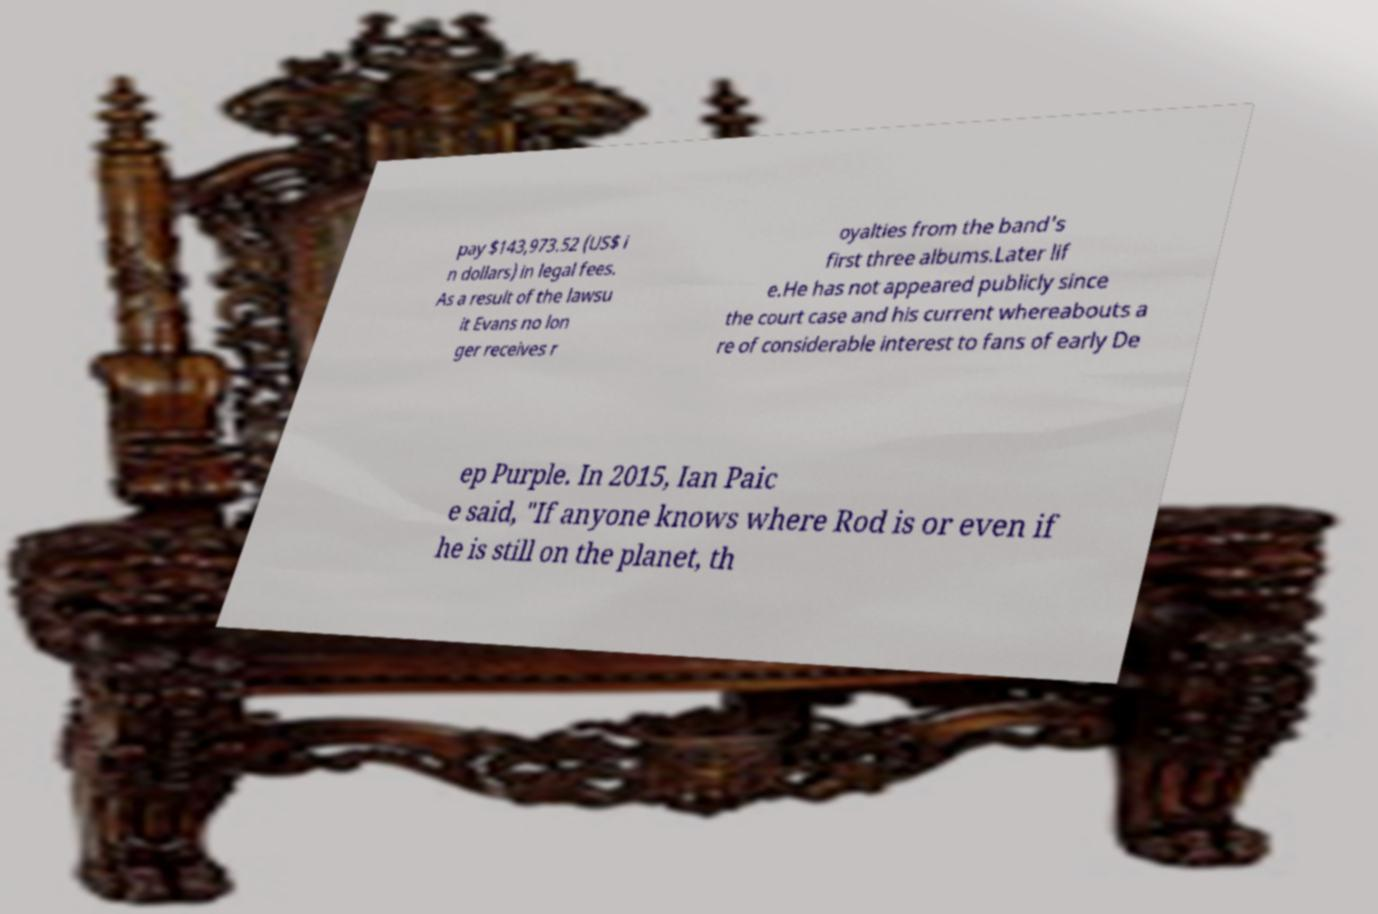For documentation purposes, I need the text within this image transcribed. Could you provide that? pay $143,973.52 (US$ i n dollars) in legal fees. As a result of the lawsu it Evans no lon ger receives r oyalties from the band's first three albums.Later lif e.He has not appeared publicly since the court case and his current whereabouts a re of considerable interest to fans of early De ep Purple. In 2015, Ian Paic e said, "If anyone knows where Rod is or even if he is still on the planet, th 